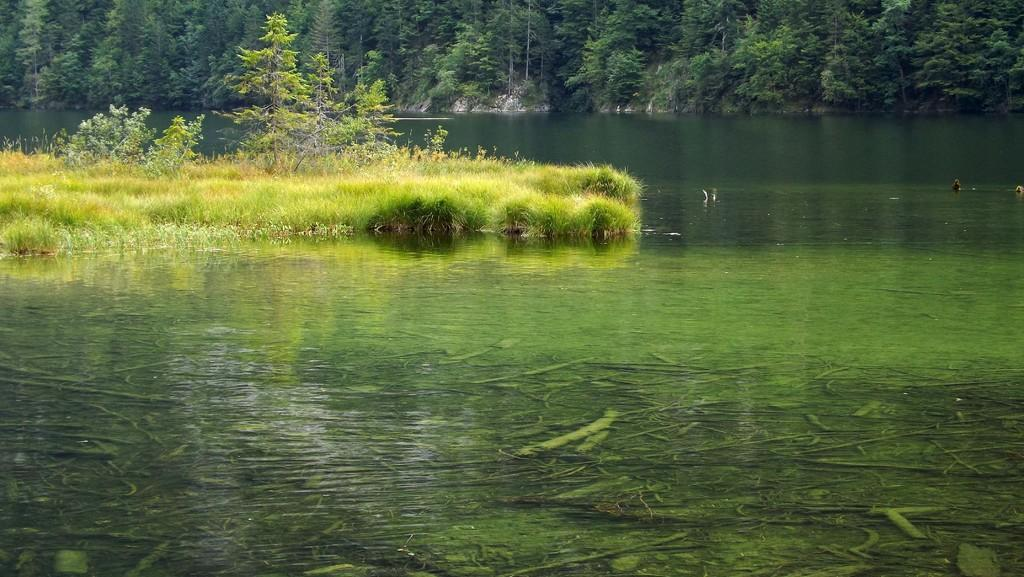What is the setting of the image? The image has an outside view. What can be seen in the middle of the river? There is a grassy area in the middle of the river. What type of vegetation is visible at the top of the image? There are trees at the top of the image. What type of hat is the person wearing while reading in the image? There are no people or hats visible in the image. How is the hose being used in the image? There is no hose present in the image. 